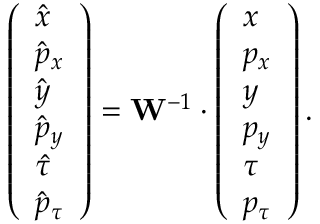<formula> <loc_0><loc_0><loc_500><loc_500>\left ( \begin{array} { l } { \hat { x } } \\ { \hat { p } _ { x } } \\ { \hat { y } } \\ { \hat { p } _ { y } } \\ { \hat { \tau } } \\ { \hat { p } _ { \tau } } \end{array} \right ) = W ^ { - 1 } \cdot \left ( \begin{array} { l } { x } \\ { p _ { x } } \\ { y } \\ { p _ { y } } \\ { \tau } \\ { p _ { \tau } } \end{array} \right ) .</formula> 